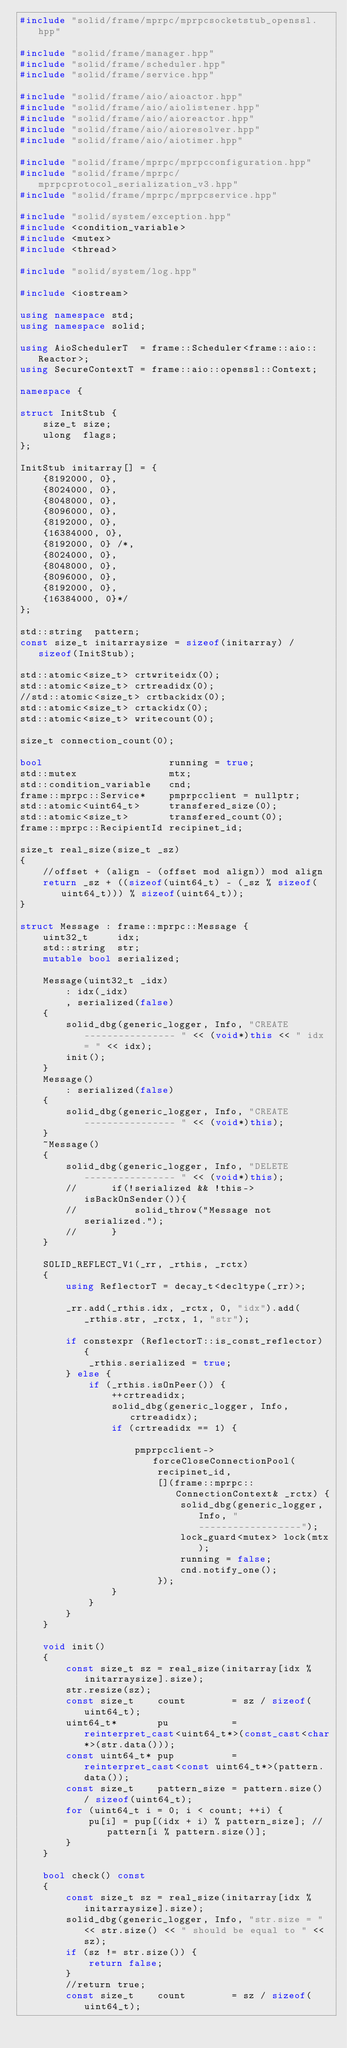<code> <loc_0><loc_0><loc_500><loc_500><_C++_>#include "solid/frame/mprpc/mprpcsocketstub_openssl.hpp"

#include "solid/frame/manager.hpp"
#include "solid/frame/scheduler.hpp"
#include "solid/frame/service.hpp"

#include "solid/frame/aio/aioactor.hpp"
#include "solid/frame/aio/aiolistener.hpp"
#include "solid/frame/aio/aioreactor.hpp"
#include "solid/frame/aio/aioresolver.hpp"
#include "solid/frame/aio/aiotimer.hpp"

#include "solid/frame/mprpc/mprpcconfiguration.hpp"
#include "solid/frame/mprpc/mprpcprotocol_serialization_v3.hpp"
#include "solid/frame/mprpc/mprpcservice.hpp"

#include "solid/system/exception.hpp"
#include <condition_variable>
#include <mutex>
#include <thread>

#include "solid/system/log.hpp"

#include <iostream>

using namespace std;
using namespace solid;

using AioSchedulerT  = frame::Scheduler<frame::aio::Reactor>;
using SecureContextT = frame::aio::openssl::Context;

namespace {

struct InitStub {
    size_t size;
    ulong  flags;
};

InitStub initarray[] = {
    {8192000, 0},
    {8024000, 0},
    {8048000, 0},
    {8096000, 0},
    {8192000, 0},
    {16384000, 0},
    {8192000, 0} /*,
    {8024000, 0},
    {8048000, 0},
    {8096000, 0},
    {8192000, 0},
    {16384000, 0}*/
};

std::string  pattern;
const size_t initarraysize = sizeof(initarray) / sizeof(InitStub);

std::atomic<size_t> crtwriteidx(0);
std::atomic<size_t> crtreadidx(0);
//std::atomic<size_t> crtbackidx(0);
std::atomic<size_t> crtackidx(0);
std::atomic<size_t> writecount(0);

size_t connection_count(0);

bool                      running = true;
std::mutex                mtx;
std::condition_variable   cnd;
frame::mprpc::Service*    pmprpcclient = nullptr;
std::atomic<uint64_t>     transfered_size(0);
std::atomic<size_t>       transfered_count(0);
frame::mprpc::RecipientId recipinet_id;

size_t real_size(size_t _sz)
{
    //offset + (align - (offset mod align)) mod align
    return _sz + ((sizeof(uint64_t) - (_sz % sizeof(uint64_t))) % sizeof(uint64_t));
}

struct Message : frame::mprpc::Message {
    uint32_t     idx;
    std::string  str;
    mutable bool serialized;

    Message(uint32_t _idx)
        : idx(_idx)
        , serialized(false)
    {
        solid_dbg(generic_logger, Info, "CREATE ---------------- " << (void*)this << " idx = " << idx);
        init();
    }
    Message()
        : serialized(false)
    {
        solid_dbg(generic_logger, Info, "CREATE ---------------- " << (void*)this);
    }
    ~Message()
    {
        solid_dbg(generic_logger, Info, "DELETE ---------------- " << (void*)this);
        //      if(!serialized && !this->isBackOnSender()){
        //          solid_throw("Message not serialized.");
        //      }
    }

    SOLID_REFLECT_V1(_rr, _rthis, _rctx)
    {
        using ReflectorT = decay_t<decltype(_rr)>;

        _rr.add(_rthis.idx, _rctx, 0, "idx").add(_rthis.str, _rctx, 1, "str");

        if constexpr (ReflectorT::is_const_reflector) {
            _rthis.serialized = true;
        } else {
            if (_rthis.isOnPeer()) {
                ++crtreadidx;
                solid_dbg(generic_logger, Info, crtreadidx);
                if (crtreadidx == 1) {

                    pmprpcclient->forceCloseConnectionPool(
                        recipinet_id,
                        [](frame::mprpc::ConnectionContext& _rctx) {
                            solid_dbg(generic_logger, Info, "------------------");
                            lock_guard<mutex> lock(mtx);
                            running = false;
                            cnd.notify_one();
                        });
                }
            }
        }
    }

    void init()
    {
        const size_t sz = real_size(initarray[idx % initarraysize].size);
        str.resize(sz);
        const size_t    count        = sz / sizeof(uint64_t);
        uint64_t*       pu           = reinterpret_cast<uint64_t*>(const_cast<char*>(str.data()));
        const uint64_t* pup          = reinterpret_cast<const uint64_t*>(pattern.data());
        const size_t    pattern_size = pattern.size() / sizeof(uint64_t);
        for (uint64_t i = 0; i < count; ++i) {
            pu[i] = pup[(idx + i) % pattern_size]; //pattern[i % pattern.size()];
        }
    }

    bool check() const
    {
        const size_t sz = real_size(initarray[idx % initarraysize].size);
        solid_dbg(generic_logger, Info, "str.size = " << str.size() << " should be equal to " << sz);
        if (sz != str.size()) {
            return false;
        }
        //return true;
        const size_t    count        = sz / sizeof(uint64_t);</code> 